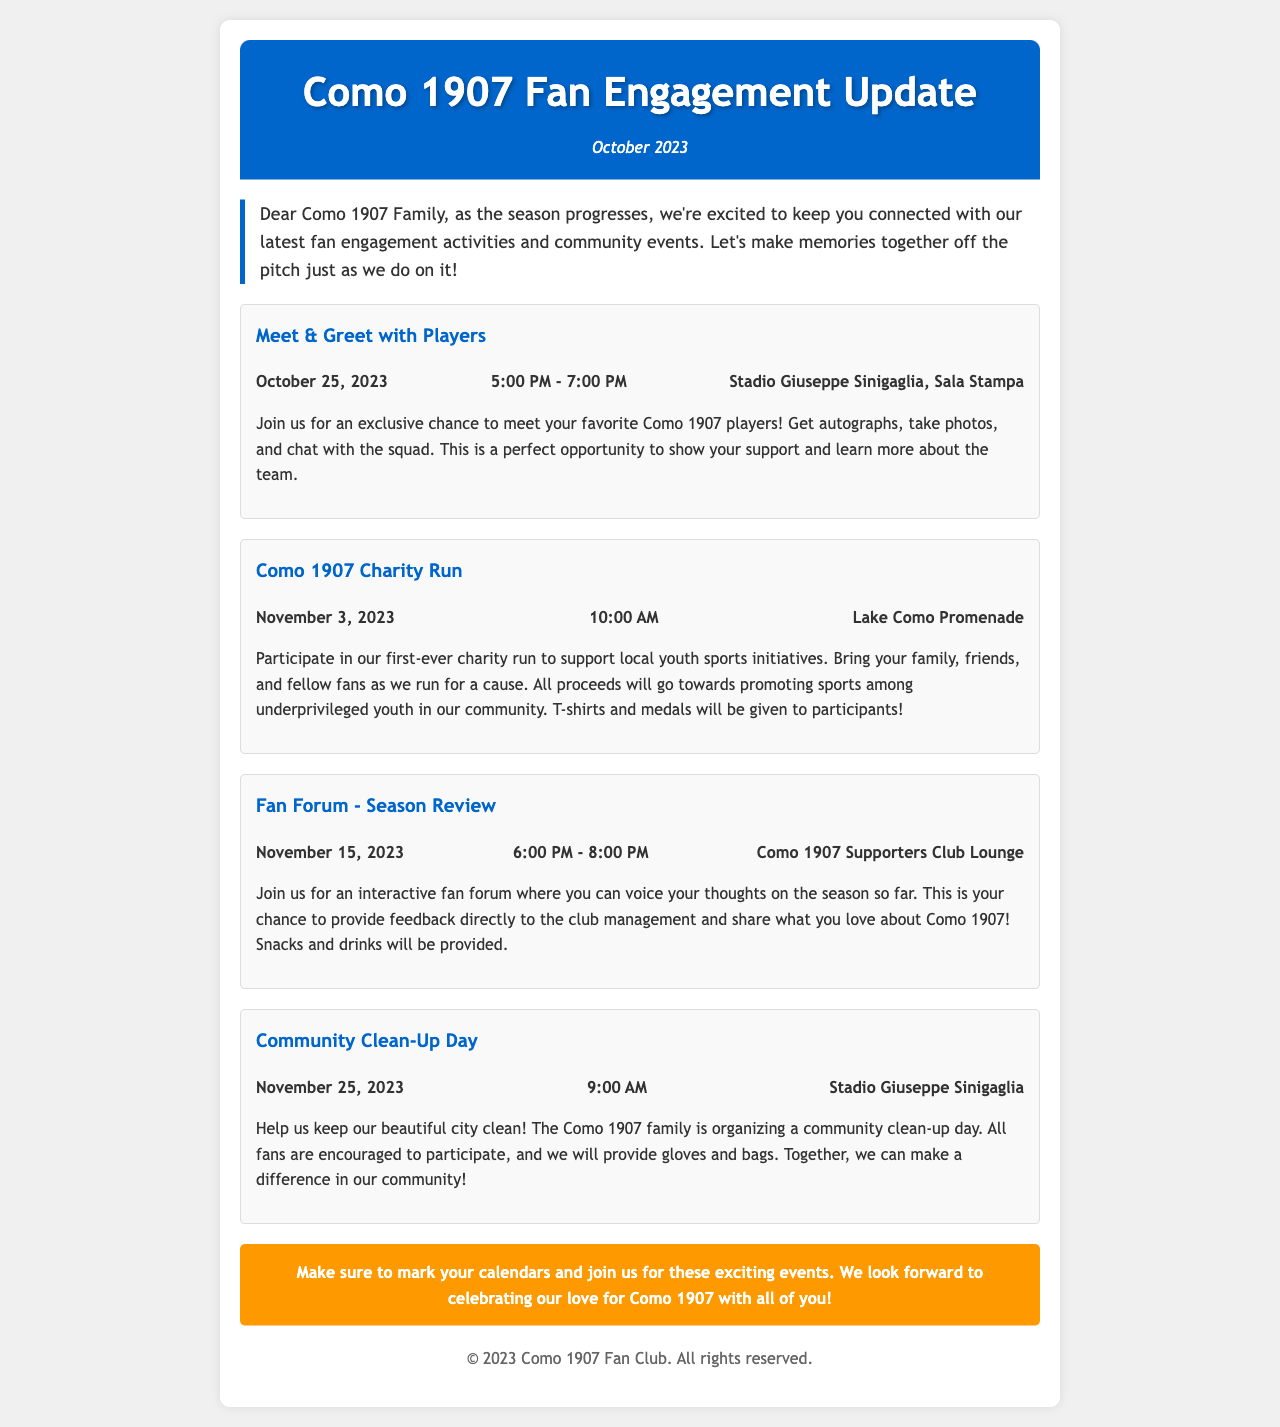What is the date of the Meet & Greet with Players? The date is clearly stated in the document.
Answer: October 25, 2023 What time does the Charity Run start? The start time for the Charity Run is provided in the event details.
Answer: 10:00 AM Where is the Fan Forum held? The location for the Fan Forum is mentioned in the event details section.
Answer: Como 1907 Supporters Club Lounge What community initiative is scheduled for November 25, 2023? The document lists various events, including community initiatives.
Answer: Community Clean-Up Day How many events are listed in the newsletter? Count the number of events mentioned in the document.
Answer: Four What is the purpose of the Charity Run? The purpose is specified in the description of the event.
Answer: To support local youth sports initiatives Which event allows fans to voice their thoughts directly to club management? The event focused on fan interaction is pointed out in the document.
Answer: Fan Forum - Season Review What is provided to participants in the Charity Run? The document mentions rewards for participants in the Charity Run.
Answer: T-shirts and medals 